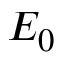<formula> <loc_0><loc_0><loc_500><loc_500>E _ { 0 }</formula> 